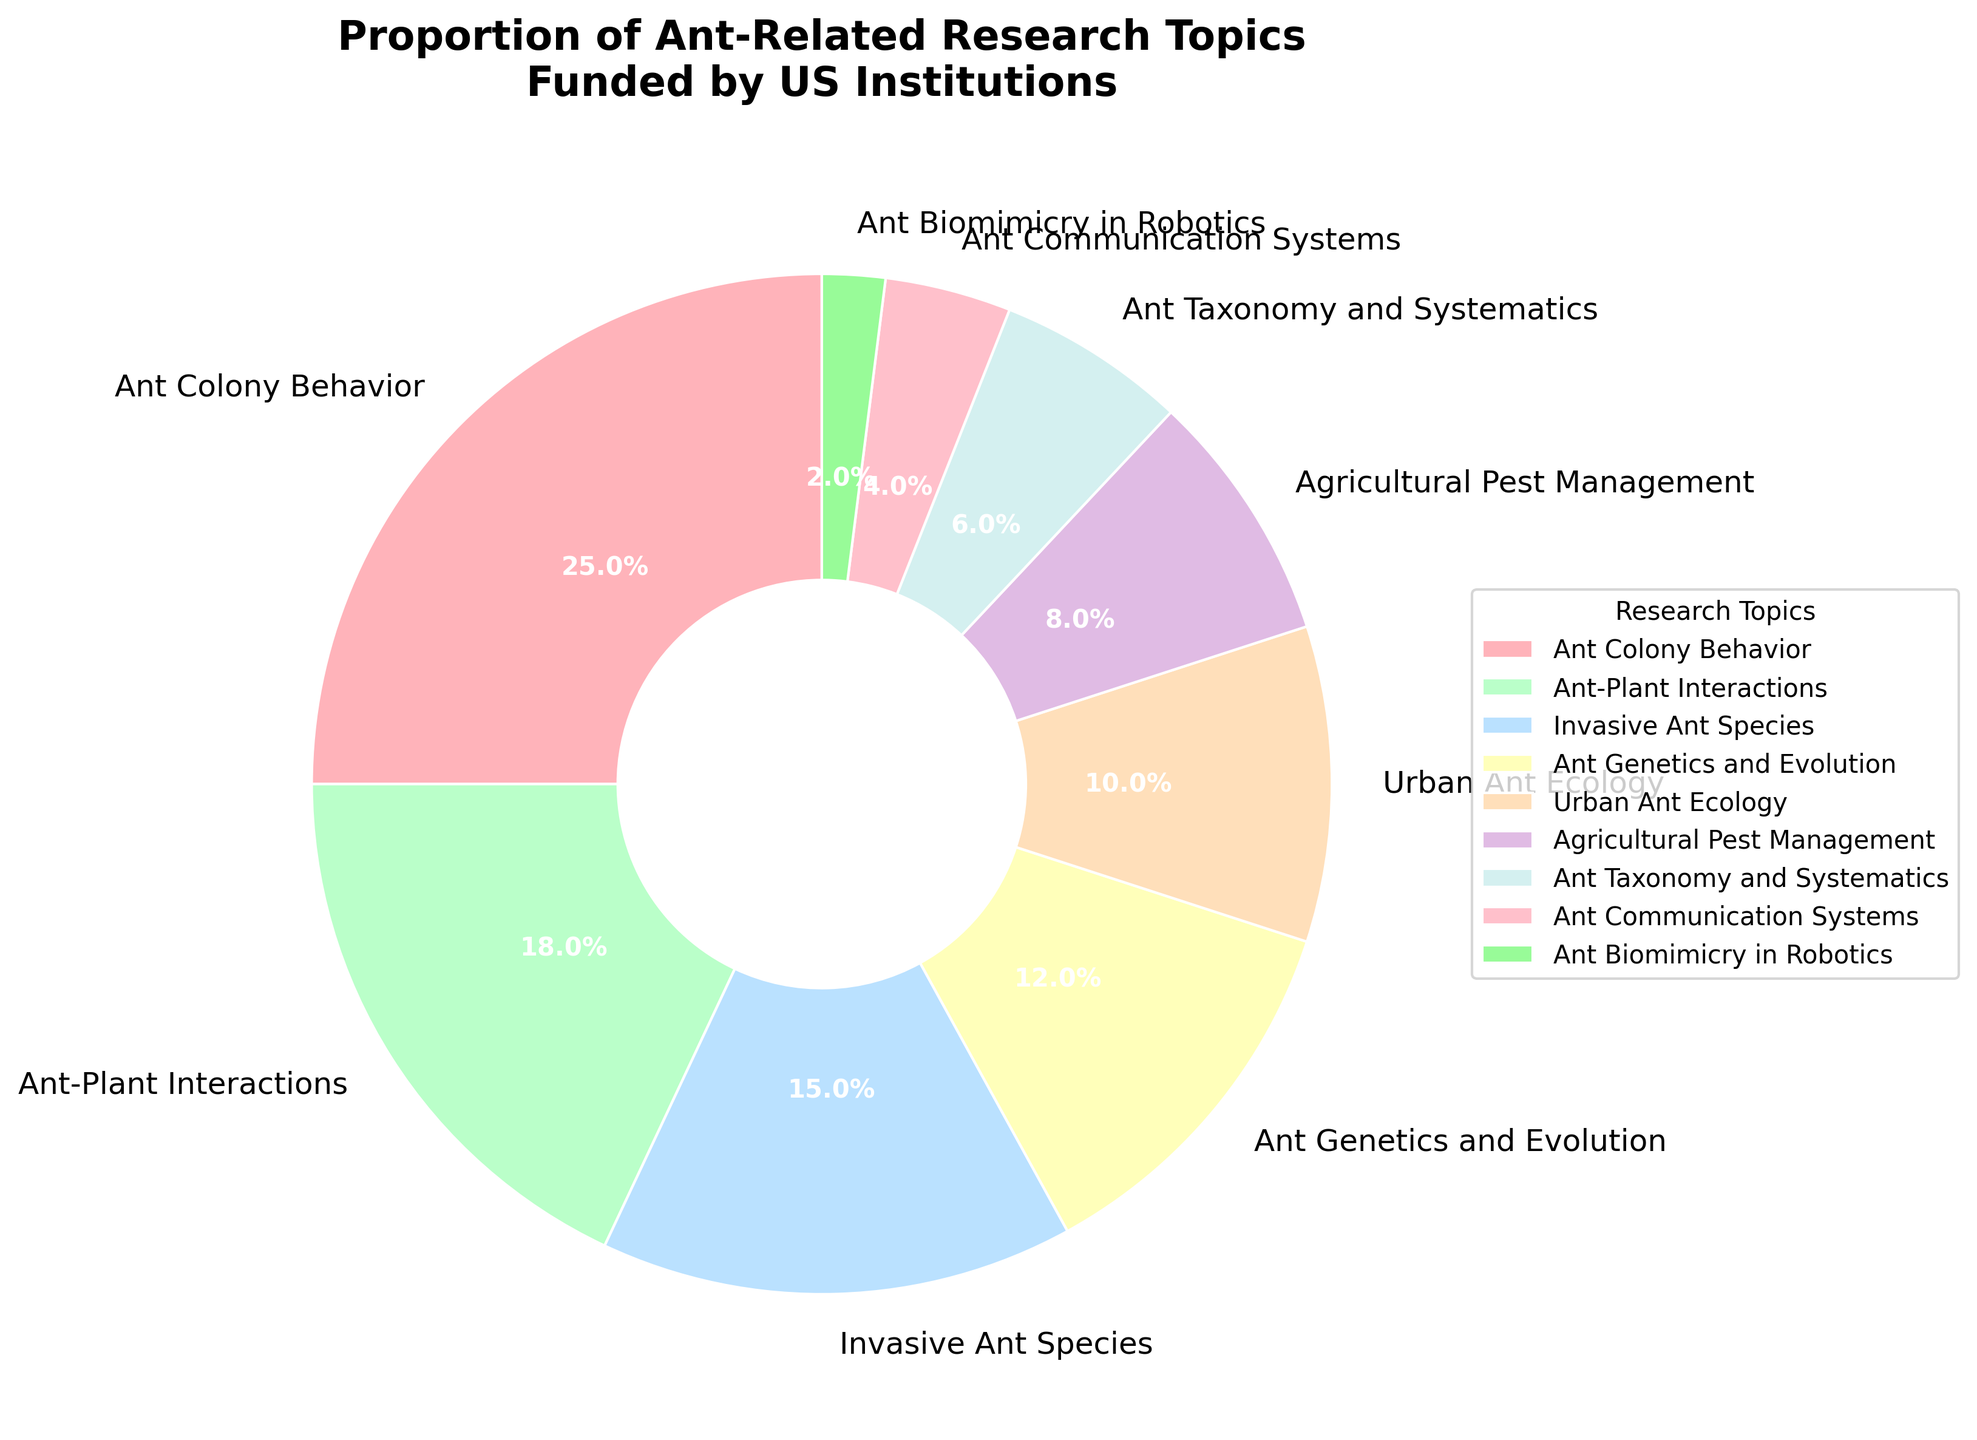What research topic has the largest proportion? The research topic with the largest proportion can be determined by looking at the segment that covers the largest area in the pie chart. "Ant Colony Behavior" has the largest proportion.
Answer: Ant Colony Behavior What is the combined percentage of "Urban Ant Ecology" and "Agricultural Pest Management"? To find the combined percentage, sum the individual percentages of "Urban Ant Ecology" and "Agricultural Pest Management". That is 10% + 8%.
Answer: 18% Which two research topics have the smallest proportions? The research topics with the smallest proportions can be identified by looking at the smallest segments in the pie chart. "Ant Communication Systems" and "Ant Biomimicry in Robotics" have the smallest proportions.
Answer: Ant Communication Systems and Ant Biomimicry in Robotics How much greater is the proportion of "Ant Colony Behavior" compared to "Ant Taxonomy and Systematics"? To find how much greater the proportion is, subtract the percentage of "Ant Taxonomy and Systematics" from "Ant Colony Behavior". That is 25% - 6%.
Answer: 19% What is the difference in percentage between "Ant-Plant Interactions" and "Invasive Ant Species"? To calculate the difference, subtract the percentage of "Invasive Ant Species" from "Ant-Plant Interactions". That is 18% - 15%.
Answer: 3% Which research topics combined make up exactly 30% of the total? To find research topics that together make up 30%, we need to find a combination of percentages that sum to 30%. "Ant Genetics and Evolution" (12%) and "Ant-Plant Interactions" (18%) combined make 30%.
Answer: Ant Genetics and Evolution and Ant-Plant Interactions Which research topic's proportion is closest to the average percentage of all topics? First, calculate the average percentage. Sum all percentages and divide by the number of topics. The total percentage sums to 100%, and there are 9 topics, so the average is 100% / 9 ≈ 11.1%. "Ant Genetics and Evolution" with 12% is closest to the average.
Answer: Ant Genetics and Evolution Is "Urban Ant Ecology" larger or smaller than "Invasive Ant Species"? By how much? Compare the percentage of "Urban Ant Ecology" (10%) and "Invasive Ant Species" (15%). Subtract the smaller percentage from the larger one. That is 15% - 10%.
Answer: Smaller by 5% What is the sum of the three smallest proportions? Identify and sum the three smallest proportions: "Ant Communication Systems" (4%), "Ant Biomimicry in Robotics" (2%), and "Ant Taxonomy and Systematics" (6%). 4% + 2% + 6%.
Answer: 12% What is the median value of all the research topic percentages? To find the median, list the percentages in ascending order and identify the middle value. The percentages are [2, 4, 6, 8, 10, 12, 15, 18, 25]. The median is the middle value in this list.
Answer: 10% 